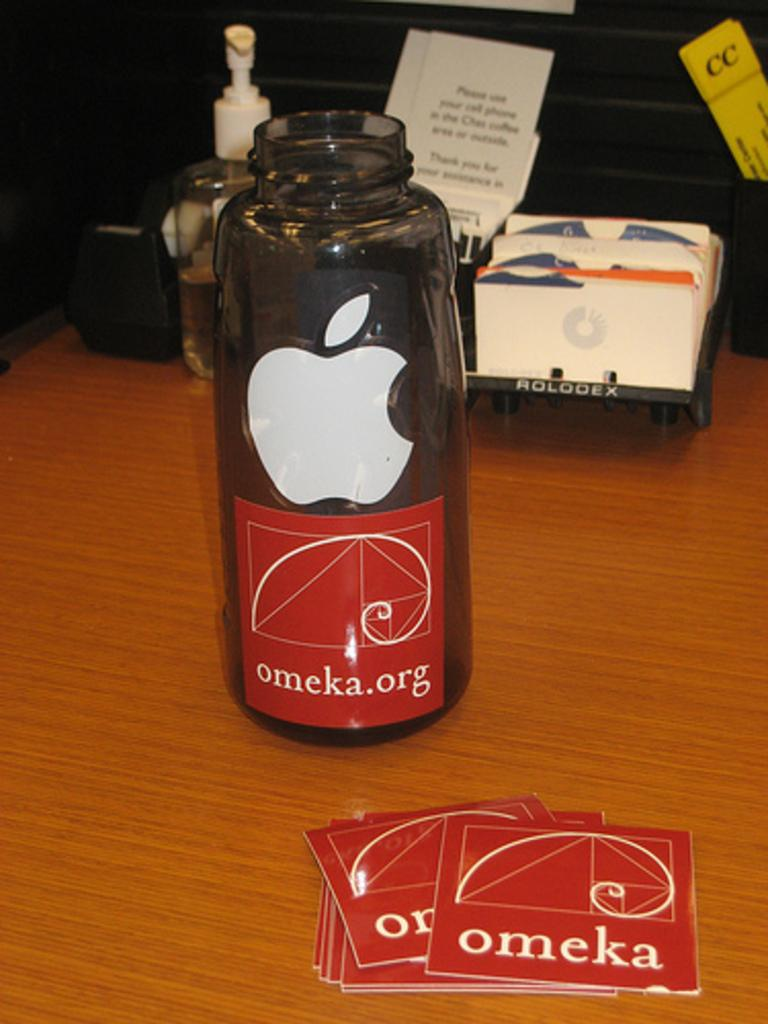<image>
Summarize the visual content of the image. a red omeka.org label sticker is seen on an apple water bottle 